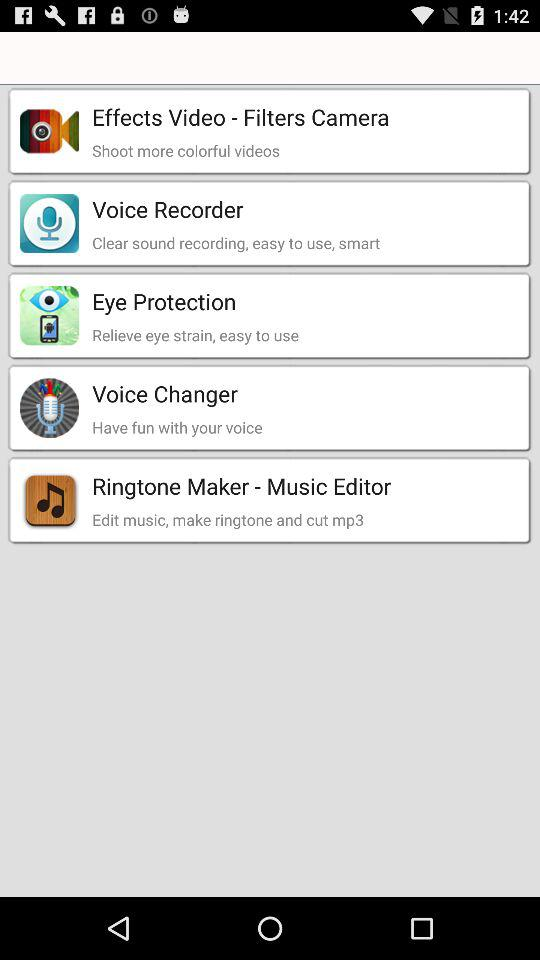Which application can we use for clear sound recording? You can use "Voice Recorder" for clear sound recording. 